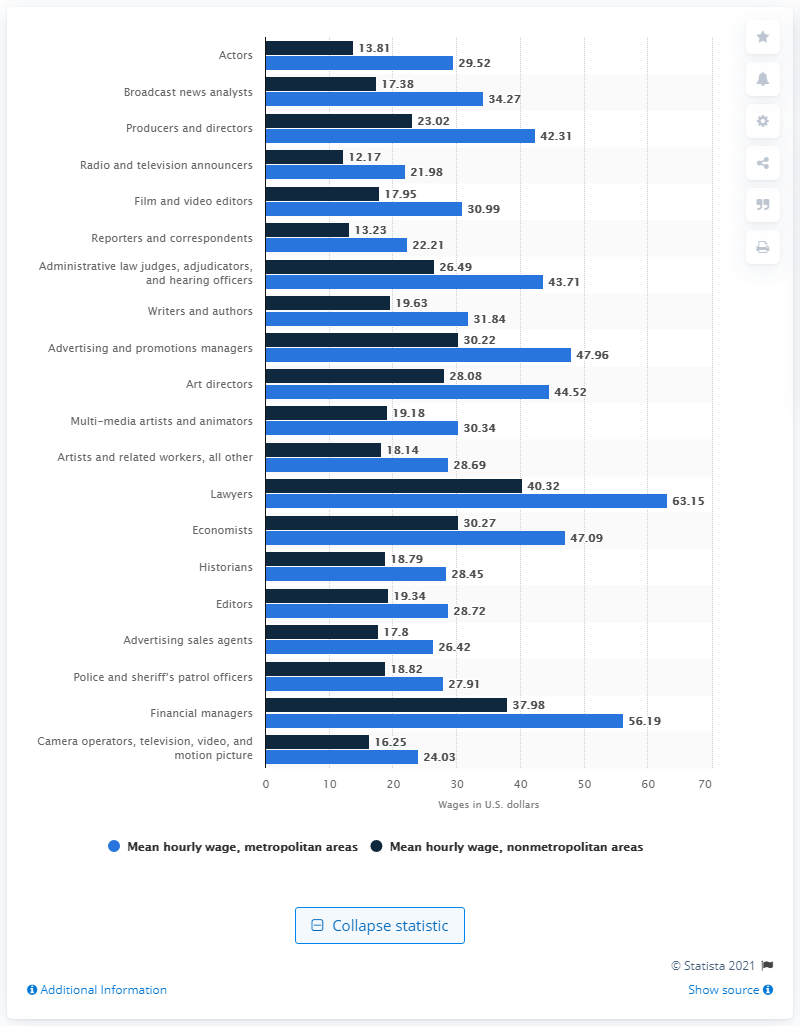Draw attention to some important aspects in this diagram. The average hourly wage in nonmetropolitan areas is 13.81. 